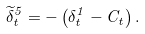Convert formula to latex. <formula><loc_0><loc_0><loc_500><loc_500>\widetilde { \delta } _ { t } ^ { 5 } = - \left ( \delta _ { t } ^ { 1 } - C _ { t } \right ) .</formula> 